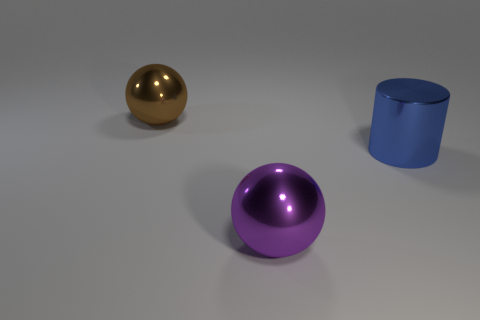Add 1 cylinders. How many objects exist? 4 Subtract all brown balls. How many balls are left? 1 Subtract all brown cylinders. Subtract all red spheres. How many cylinders are left? 1 Subtract all blue cylinders. How many purple balls are left? 1 Subtract all green cylinders. Subtract all brown shiny spheres. How many objects are left? 2 Add 3 brown metallic things. How many brown metallic things are left? 4 Add 2 small matte spheres. How many small matte spheres exist? 2 Subtract 1 blue cylinders. How many objects are left? 2 Subtract all balls. How many objects are left? 1 